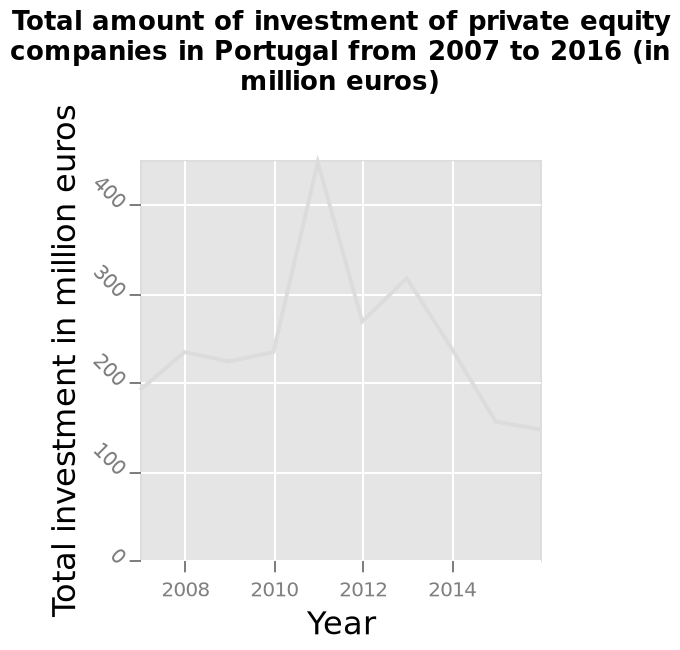<image>
What is the minimum amount of investment made by private equity companies in Portugal from 2007 to 2016?  The minimum amount of investment made by private equity companies in Portugal from 2007 to 2016 is 0 million euros. What is the maximum amount of investment made by private equity companies in Portugal from 2007 to 2016?  The maximum amount of investment made by private equity companies in Portugal from 2007 to 2016 is 400 million euros. In which year did the total investment by private equity companies in Portugal reach its highest point?  The given description does not specify the year in which the total investment by private equity companies in Portugal reached its highest point. What was the total amount of investments in 2011? The total amount of investments in 2011 was over 400 million euros. please summary the statistics and relations of the chart There was a huge jump in investments in 2011 topping over 400 million euros. 